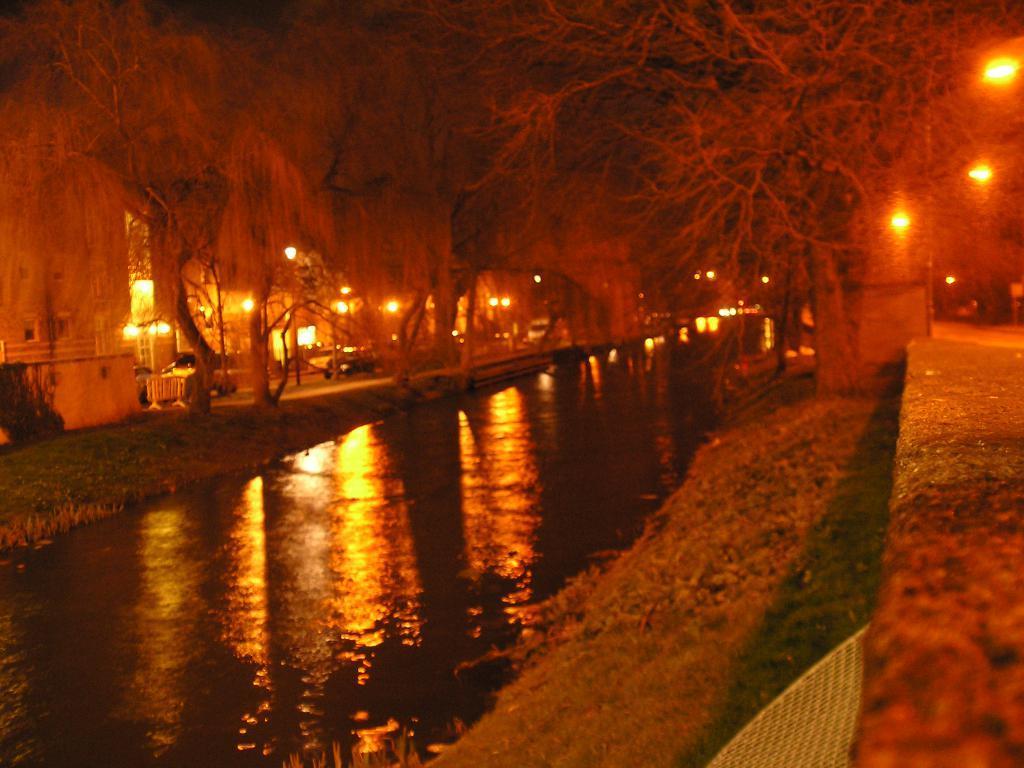Could you give a brief overview of what you see in this image? In this epicure we can see water, few trees, vehicles, lights and buildings. 